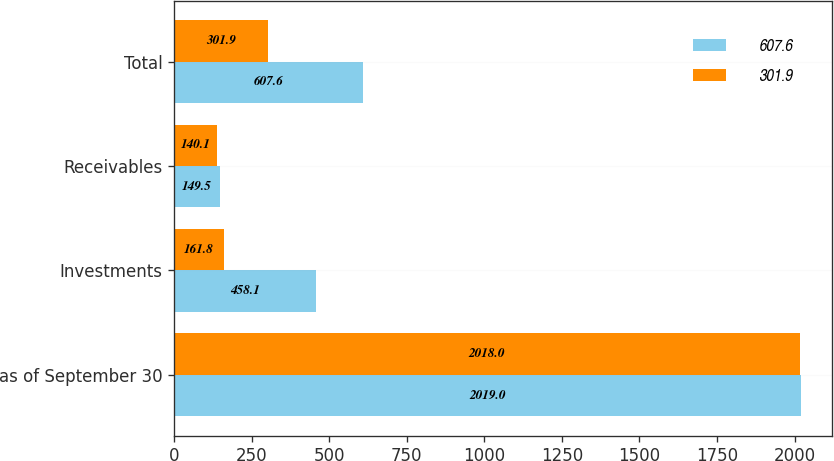<chart> <loc_0><loc_0><loc_500><loc_500><stacked_bar_chart><ecel><fcel>as of September 30<fcel>Investments<fcel>Receivables<fcel>Total<nl><fcel>607.6<fcel>2019<fcel>458.1<fcel>149.5<fcel>607.6<nl><fcel>301.9<fcel>2018<fcel>161.8<fcel>140.1<fcel>301.9<nl></chart> 